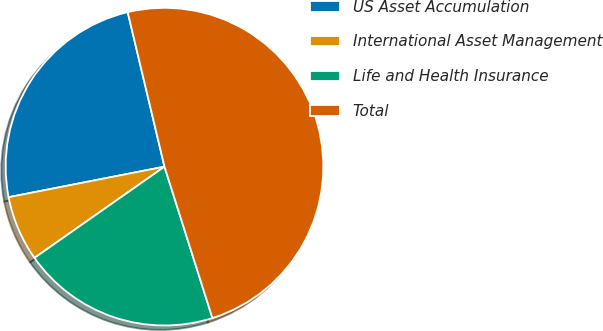Convert chart. <chart><loc_0><loc_0><loc_500><loc_500><pie_chart><fcel>US Asset Accumulation<fcel>International Asset Management<fcel>Life and Health Insurance<fcel>Total<nl><fcel>24.36%<fcel>6.66%<fcel>20.14%<fcel>48.84%<nl></chart> 